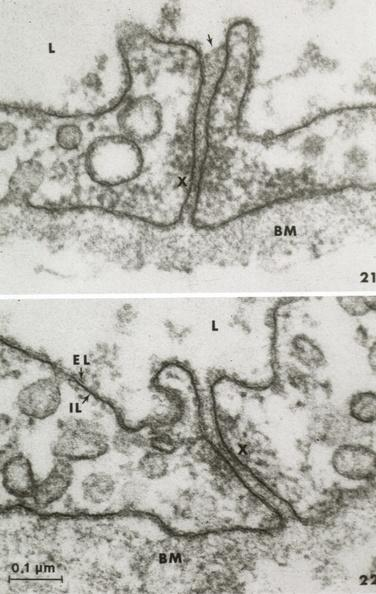what is present?
Answer the question using a single word or phrase. Vasculature 